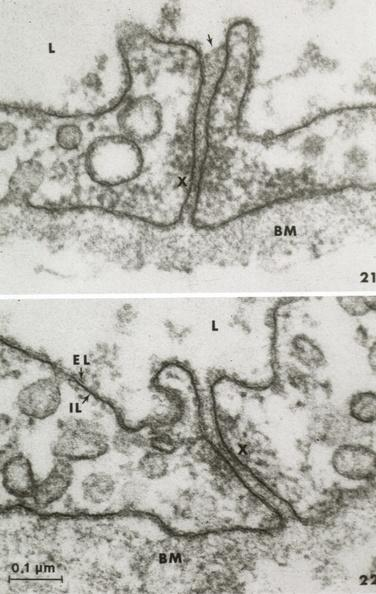what is present?
Answer the question using a single word or phrase. Vasculature 